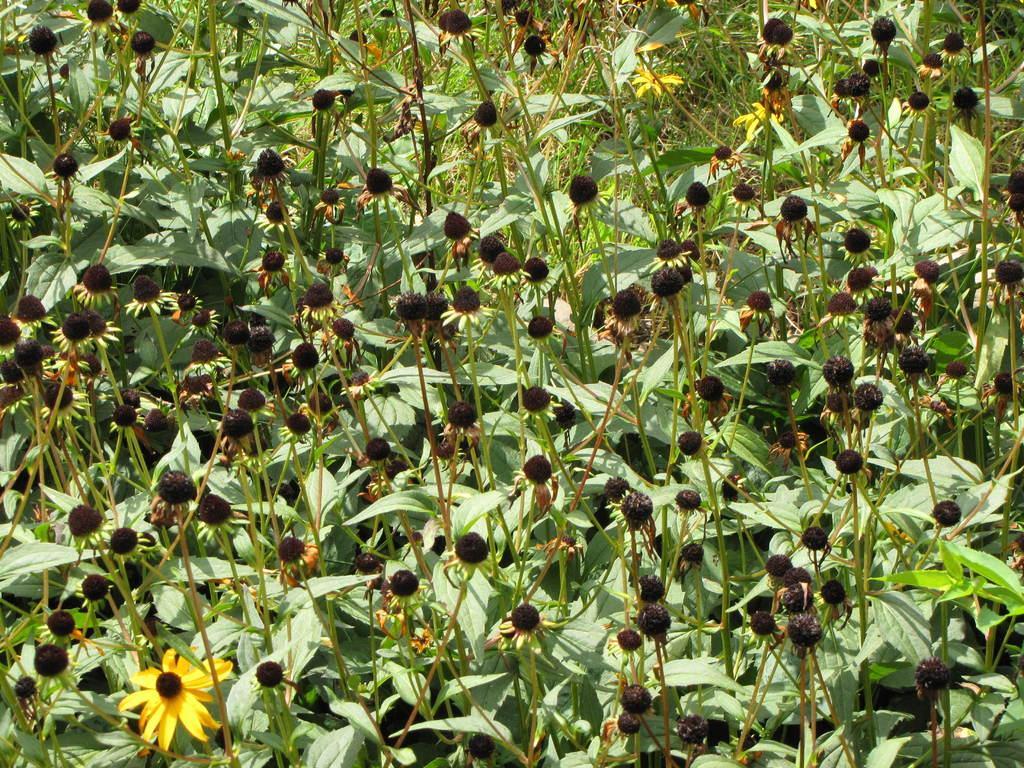Describe this image in one or two sentences. There are plants having green color leaves and seeds. Some of them are having yellow color flowers. In the background, there is grass on the ground. 